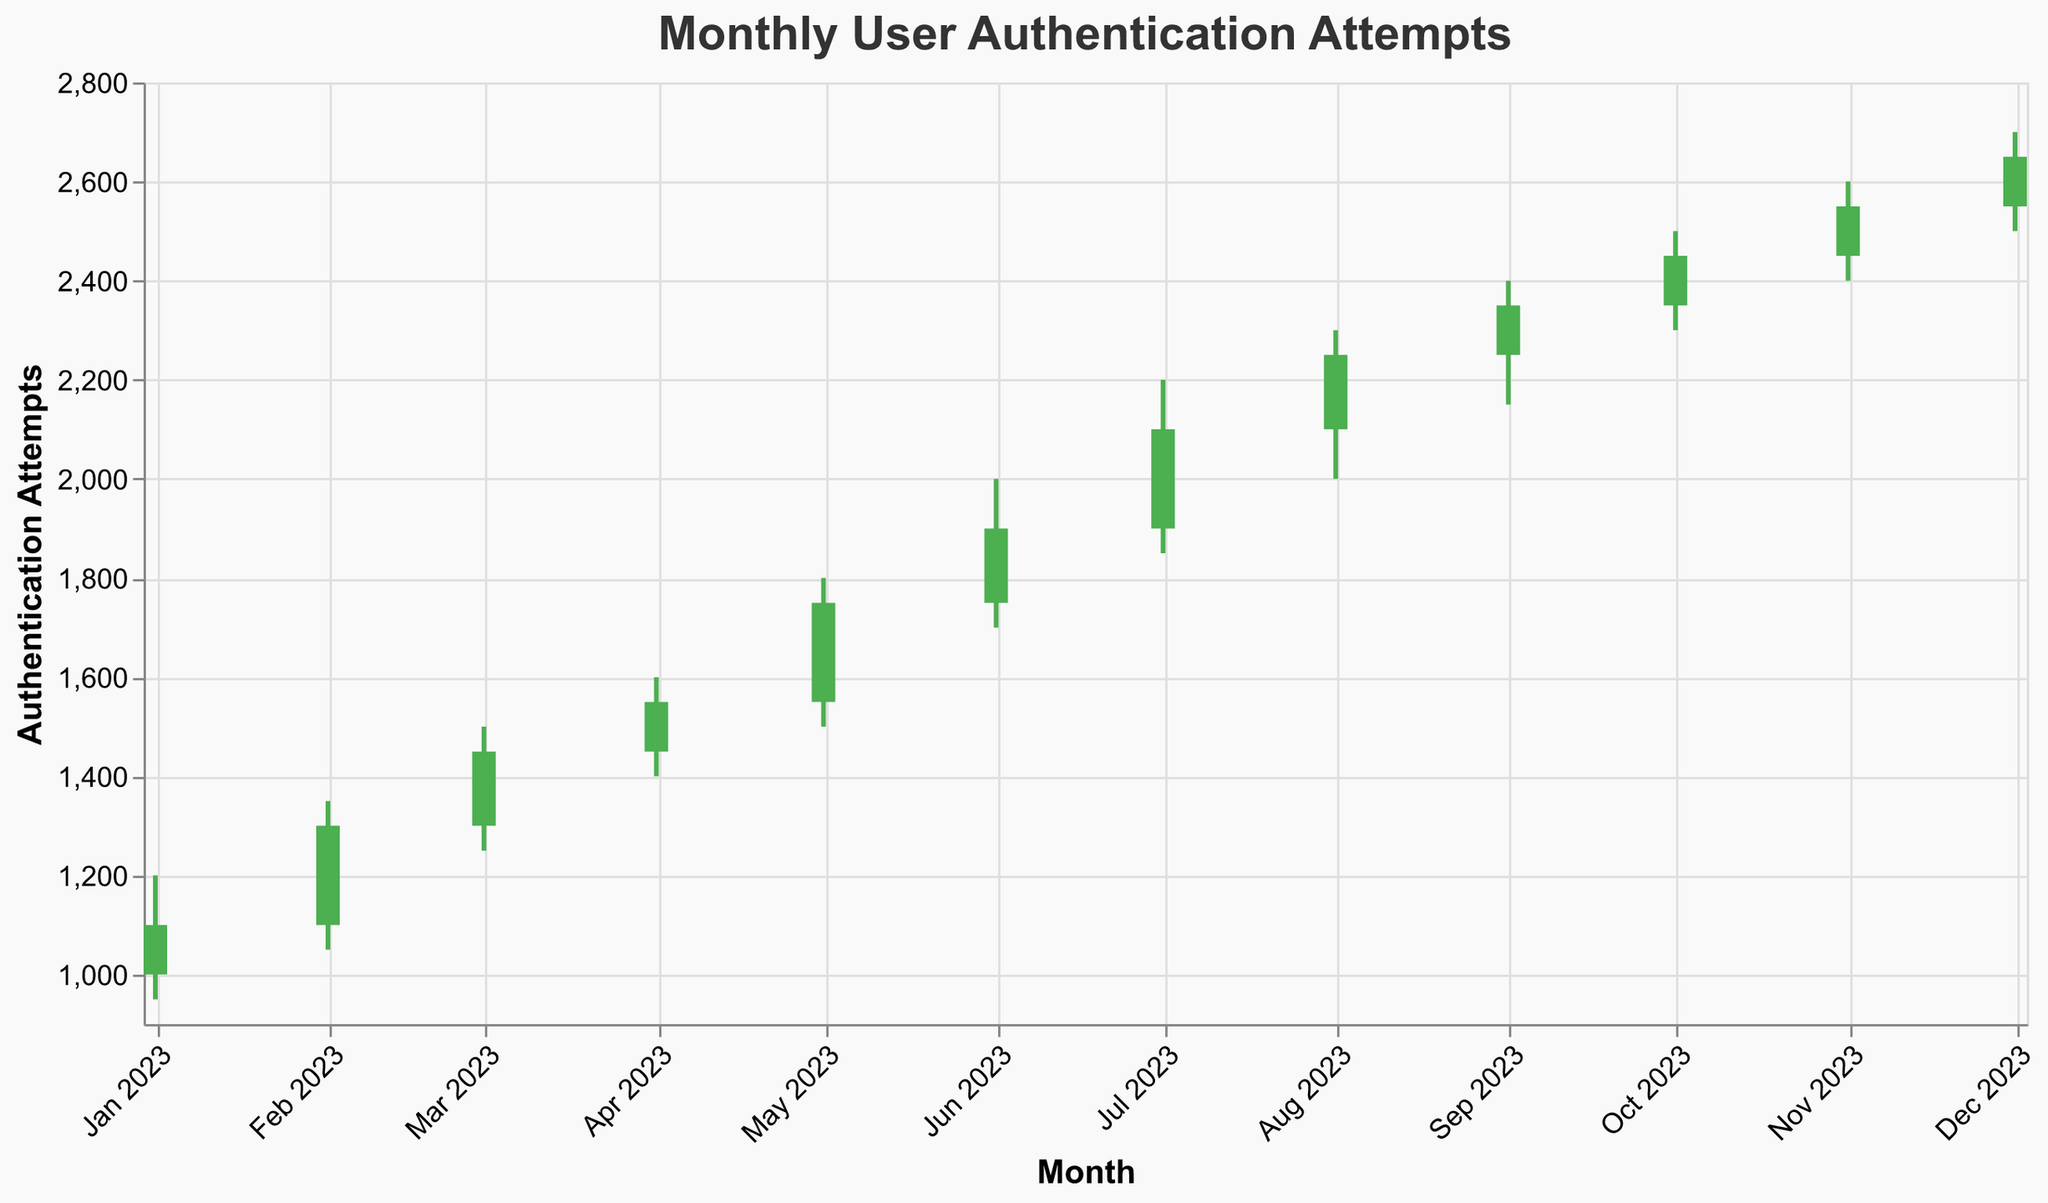What is the title of the figure? The title is displayed prominently at the top of the chart. It reads "Monthly User Authentication Attempts".
Answer: Monthly User Authentication Attempts How many months of data are displayed in the figure? The x-axis represents months, starting from January 2023 to December 2023, which totals 12 months.
Answer: 12 What color indicates a month where the closing value is higher than the opening value? The color used for months where the closing value is higher than the opening value (indicating a net increase in authentication attempts) is green.
Answer: Green What is the highest value recorded on the y-axis? The y-axis measures authentication attempts, with the highest value indicated on the scale being 2800.
Answer: 2800 How many months have their high points greater than 2000 authentication attempts? By visually inspecting the chart, the months from June to December have their high points exceeding 2000. There are 7 such months.
Answer: 7 Which month experienced the highest increase in authentication attempts from open to close? To determine this, we compare the difference (Close - Open) for each month. July has an open value of 1900 and a close value of 2100 (difference = 200), which is the largest increase among all months.
Answer: July In which month was the ratio of failed logins to successful logins highest? We determine this by calculating the ratio of FailedLogins to SuccessfulLogins for each month. February has the highest ratio (200/1150 ≈ 0.174) compared to other months.
Answer: February What is the trend of the closing values from January to December? By visually following the pattern of the closing values from January (1100) to December (2650), we observe a consistent upward trend.
Answer: Upward trend Which month had the smallest range between its high and low values? The range is calculated by subtracting the low value from the high value for each month. January has the smallest range (1200 - 950 = 250).
Answer: January What is the average number of successful logins per month for the year? Add all the successful logins for each month and divide by 12. (950 + 1150 + 1300 + 1400 + 1600 + 1750 + 1950 + 2100 + 2200 + 2300 + 2400 + 2500) / 12 = 1863.33
Answer: 1863.33 